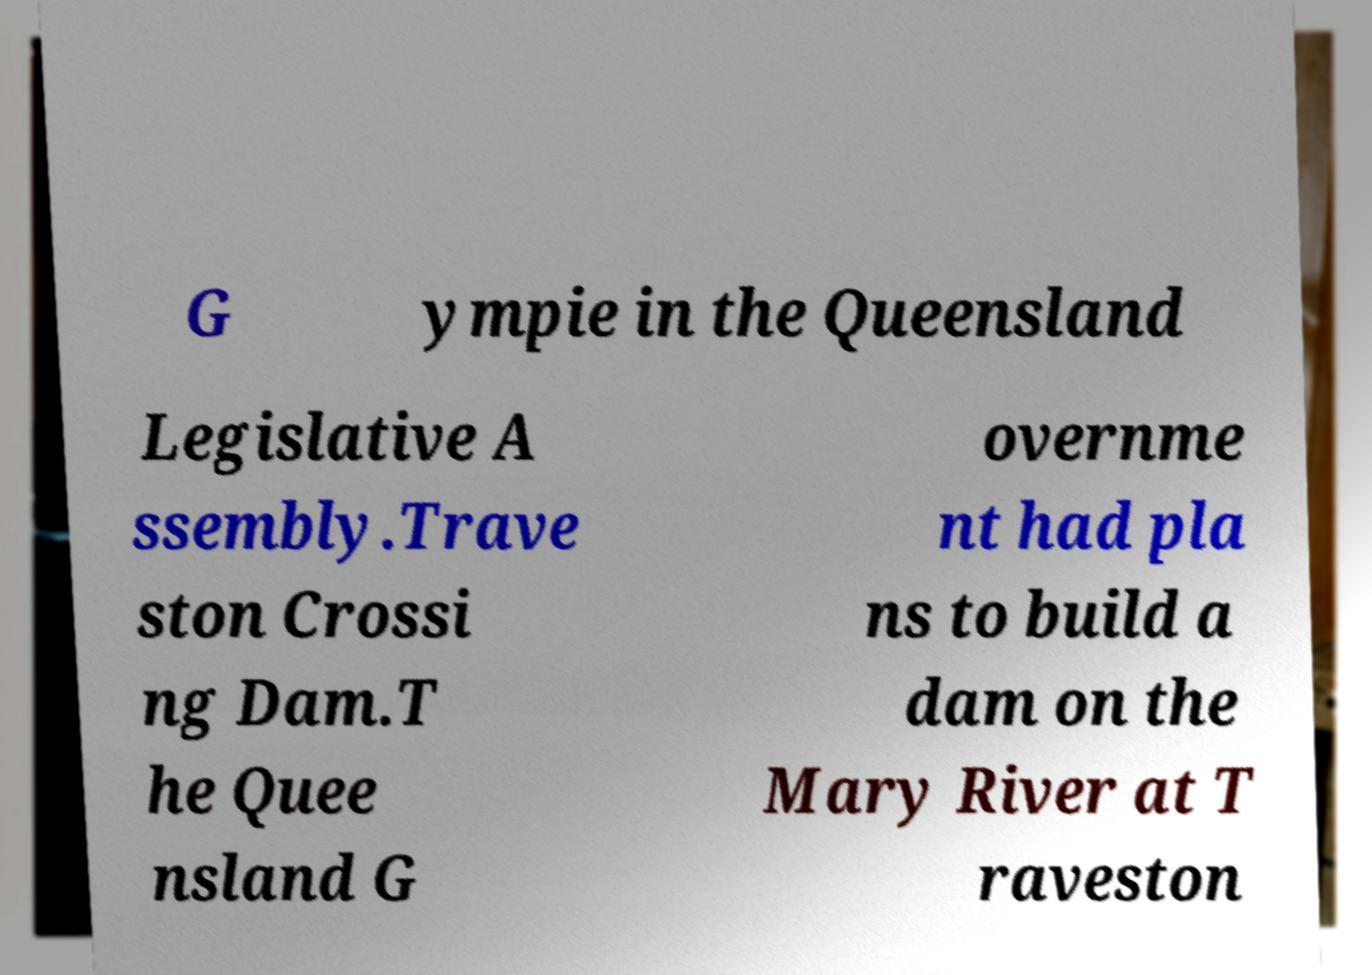Can you accurately transcribe the text from the provided image for me? G ympie in the Queensland Legislative A ssembly.Trave ston Crossi ng Dam.T he Quee nsland G overnme nt had pla ns to build a dam on the Mary River at T raveston 